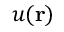<formula> <loc_0><loc_0><loc_500><loc_500>u ( r )</formula> 